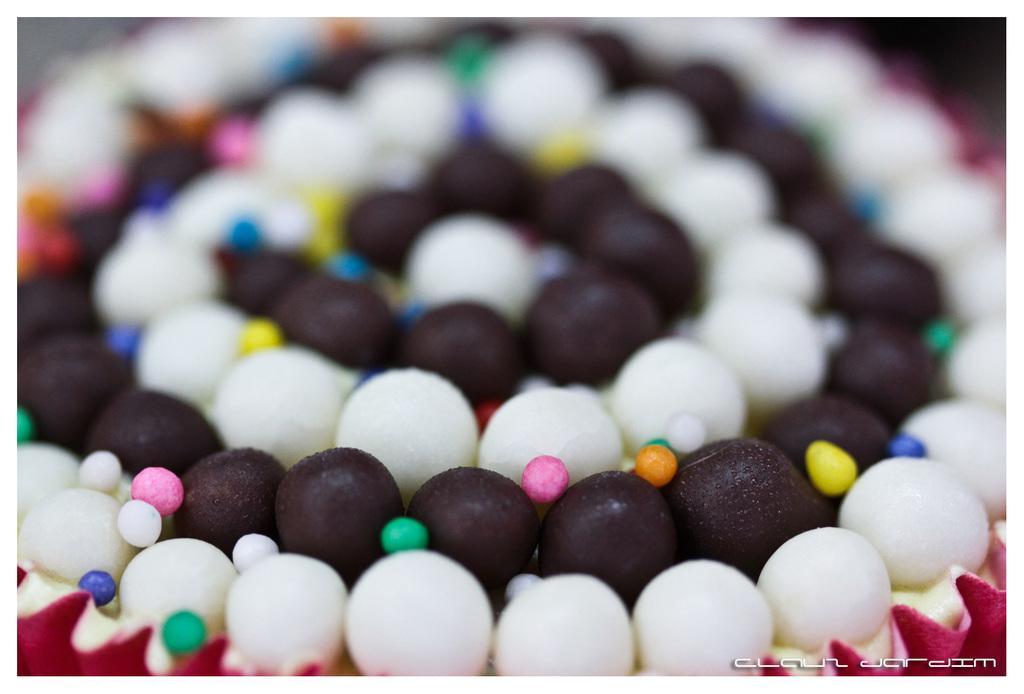How would you summarize this image in a sentence or two? In this image we can see a food item, there are brown and white balls, there are colored balls on it. 